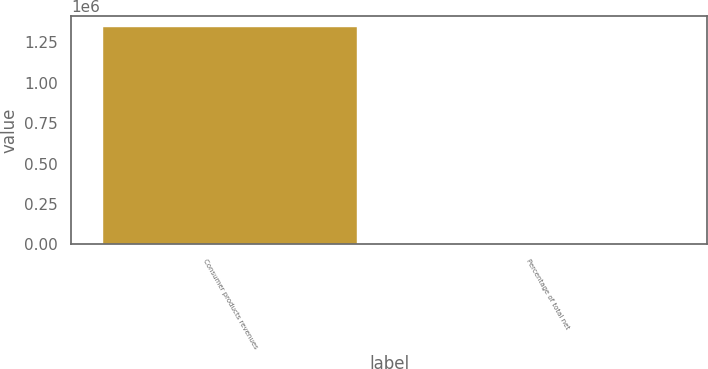<chart> <loc_0><loc_0><loc_500><loc_500><bar_chart><fcel>Consumer products revenues<fcel>Percentage of total net<nl><fcel>1.34306e+06<fcel>52<nl></chart> 